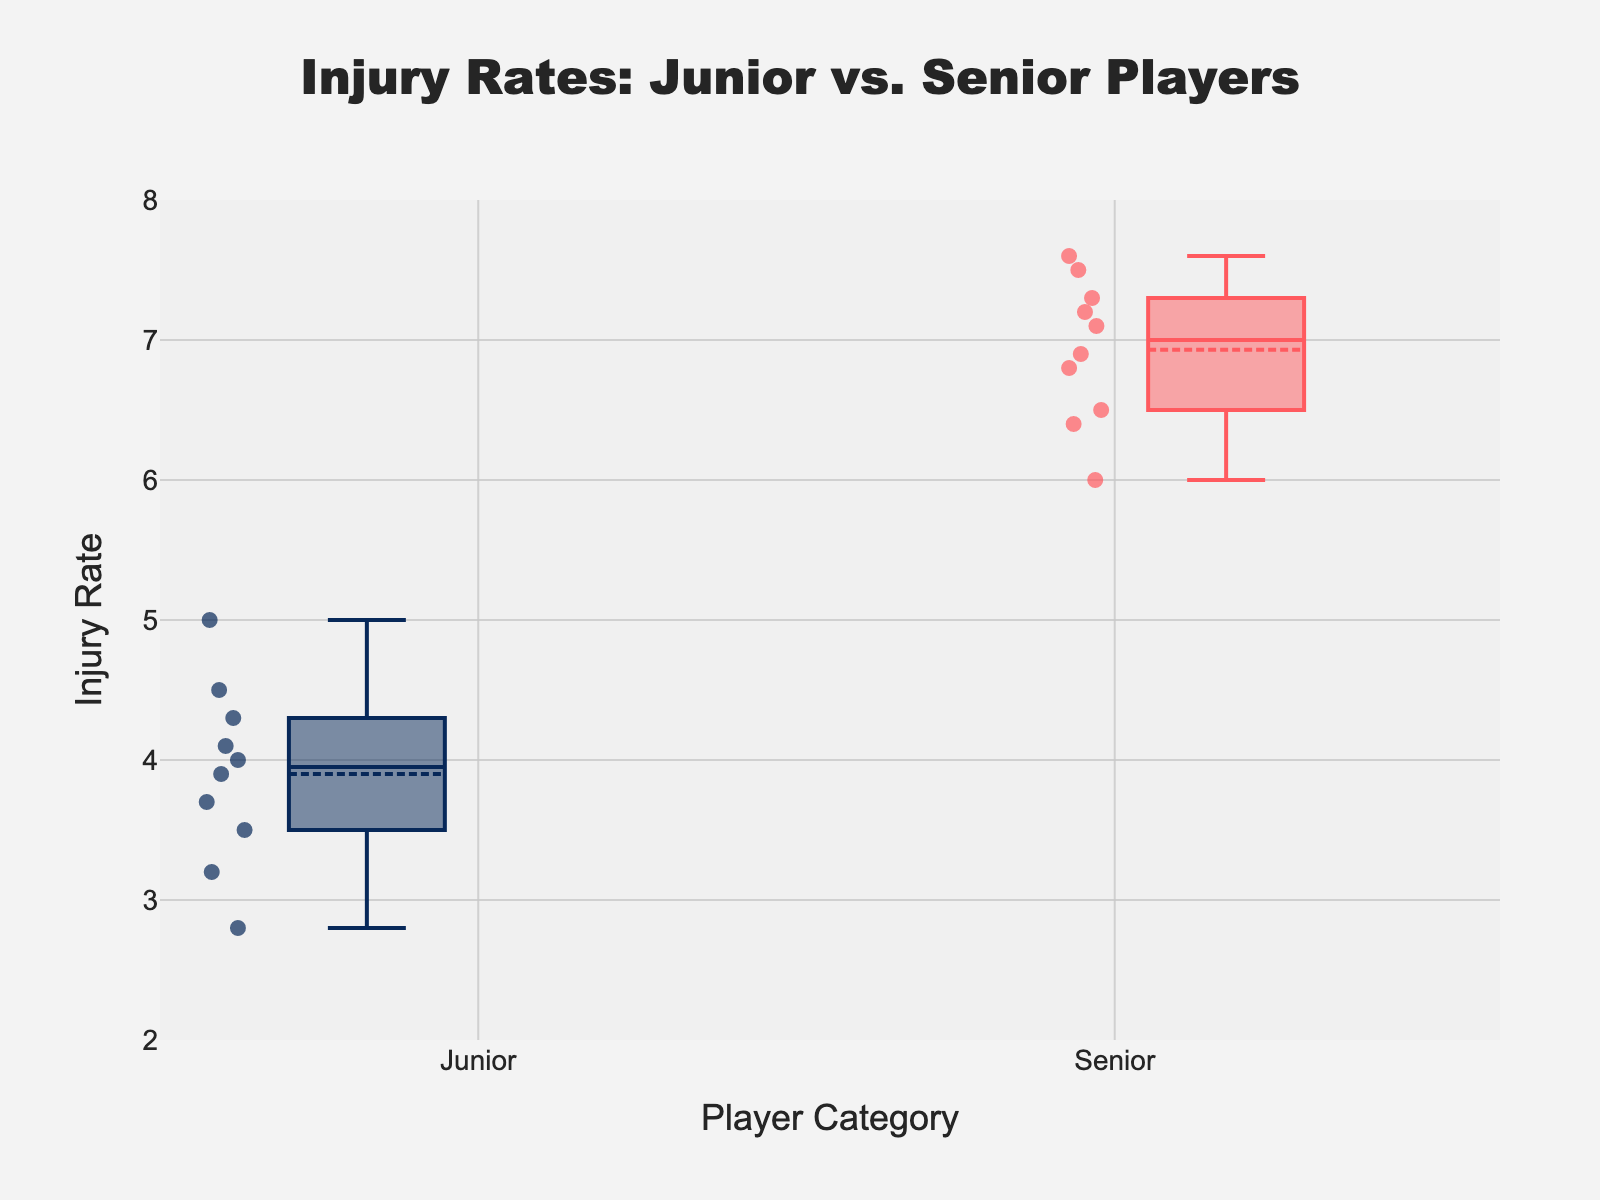What is the title of the plot? The title is given at the top of the figure and can be read directly. The title often provides a brief summary of what the plot represents.
Answer: Injury Rates: Junior vs. Senior Players What is the x-axis labeled as? The x-axis label can be read directly from the figure, which generally tells us the categories or groups being compared.
Answer: Player Category What is the range of the y-axis? The y-axis range is indicated by the start and end values specified on the y-axis. This range shows the minimum and maximum values plotted.
Answer: 2 to 8 Which group has the higher median injury rate? Look at the horizontal line inside each box that represents the median of that group. Compare these lines between the groups.
Answer: Senior What is the approximate median injury rate for Junior players? This can be determined by locating the line inside the box plot for Junior players, which represents the median value.
Answer: 4.0 Which group shows a greater spread in injury rates? The spread of injury rates can be assessed by looking at the interquartile range (IQR), represented by the height of each box. Compare the height of the boxes between the groups.
Answer: Senior What is the interquartile range (IQR) for Senior players? To find the IQR, locate the first quartile (bottom of the box) and third quartile (top of the box) for Senior players. Subtract the first quartile value from the third quartile value.
Answer: Approximately 6.5 to 7.3, so IQR ≈ 0.8 How do the mean values compare between Junior and Senior players? The means are typically marked by a dot or another indicator within the box. Compare the positions of these indicators between the groups.
Answer: The mean for Seniors is higher than that for Juniors What is the highest recorded injury rate for Senior players? The highest value is represented by the topmost point in the Senior box plot. This is the maximum data point that isn't considered an outlier.
Answer: 7.6 Which group has more variability in injury rates? Variability can be assessed by looking at the whiskers, which represent the range of data. Longer whiskers indicate higher variability.
Answer: Senior 